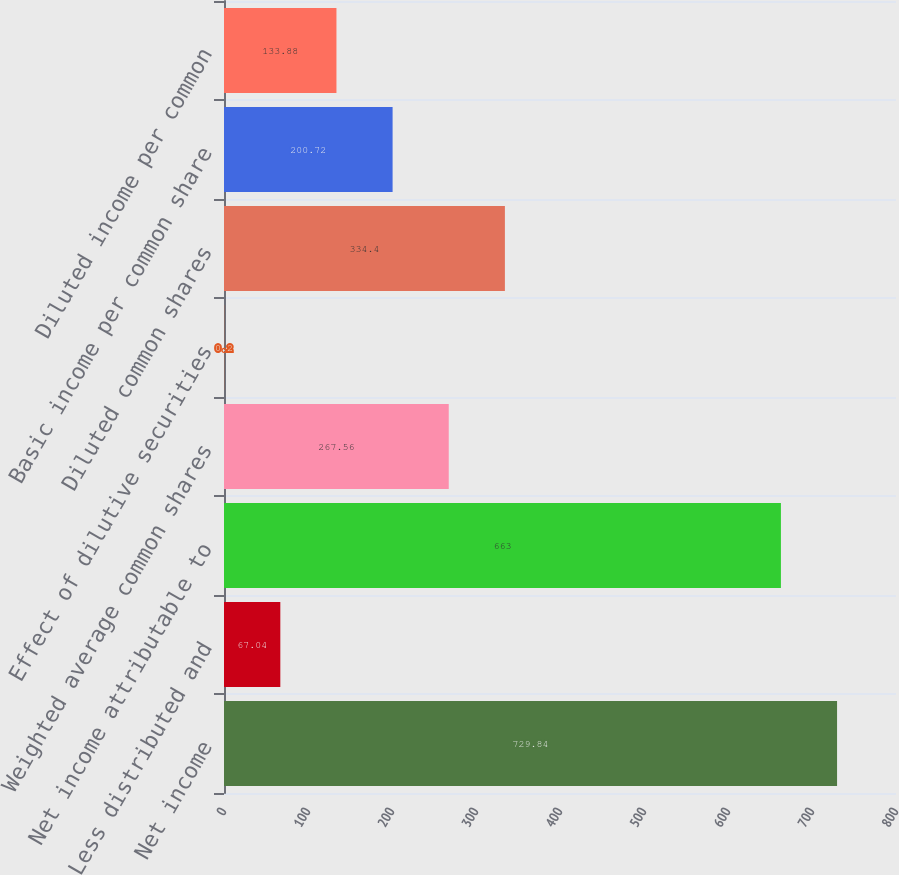Convert chart. <chart><loc_0><loc_0><loc_500><loc_500><bar_chart><fcel>Net income<fcel>Less distributed and<fcel>Net income attributable to<fcel>Weighted average common shares<fcel>Effect of dilutive securities<fcel>Diluted common shares<fcel>Basic income per common share<fcel>Diluted income per common<nl><fcel>729.84<fcel>67.04<fcel>663<fcel>267.56<fcel>0.2<fcel>334.4<fcel>200.72<fcel>133.88<nl></chart> 